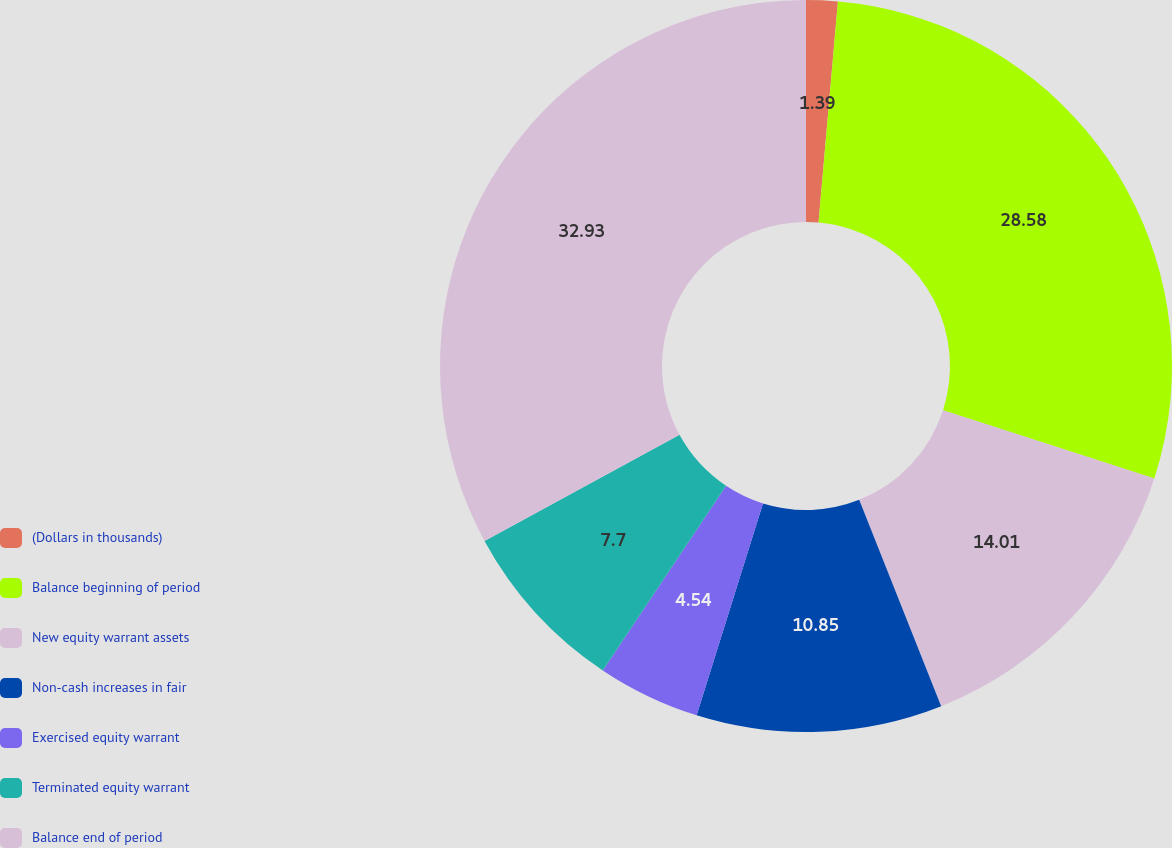Convert chart to OTSL. <chart><loc_0><loc_0><loc_500><loc_500><pie_chart><fcel>(Dollars in thousands)<fcel>Balance beginning of period<fcel>New equity warrant assets<fcel>Non-cash increases in fair<fcel>Exercised equity warrant<fcel>Terminated equity warrant<fcel>Balance end of period<nl><fcel>1.39%<fcel>28.58%<fcel>14.01%<fcel>10.85%<fcel>4.54%<fcel>7.7%<fcel>32.93%<nl></chart> 